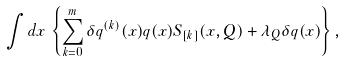<formula> <loc_0><loc_0><loc_500><loc_500>\int { d } x \, \left \{ \sum _ { k = 0 } ^ { m } \delta q ^ { ( k ) } ( x ) q ( x ) S _ { [ k ] } ( x , Q ) + \lambda _ { Q } \delta q ( x ) \right \} ,</formula> 